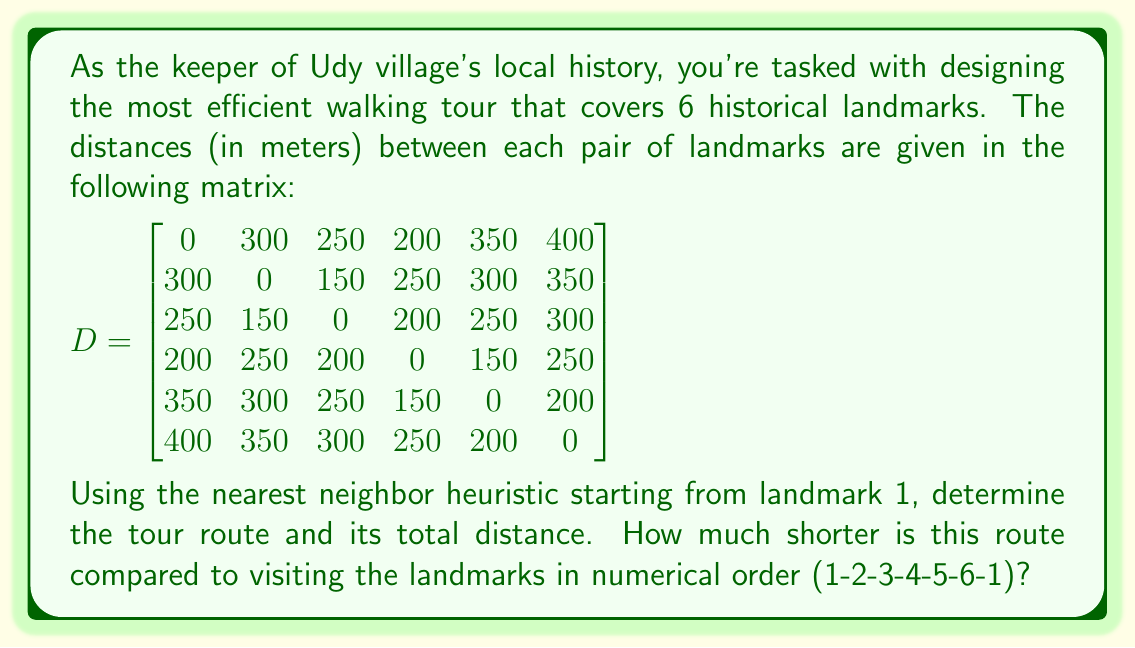Can you answer this question? To solve this problem, we'll use the nearest neighbor heuristic and compare it to the numerical order tour.

1. Nearest Neighbor Heuristic:
   Start at landmark 1 and always move to the nearest unvisited landmark.

   Step 1: Start at 1
   Step 2: Nearest to 1 is 4 (200m)
   Step 3: Nearest to 4 is 5 (150m)
   Step 4: Nearest to 5 is 6 (200m)
   Step 5: Nearest to 6 is 3 (300m)
   Step 6: Only 2 remains (150m)
   Step 7: Return to 1 (300m)

   Route: 1-4-5-6-3-2-1
   Total distance: $200 + 150 + 200 + 300 + 150 + 300 = 1300$ meters

2. Numerical Order Tour:
   Route: 1-2-3-4-5-6-1
   Distance: $300 + 150 + 200 + 150 + 200 + 400 = 1400$ meters

3. Difference in distance:
   $1400 - 1300 = 100$ meters

The nearest neighbor heuristic produces a tour that is 100 meters shorter than the numerical order tour.
Answer: The most efficient route using the nearest neighbor heuristic is 1-4-5-6-3-2-1, with a total distance of 1300 meters. This route is 100 meters shorter than the numerical order tour. 